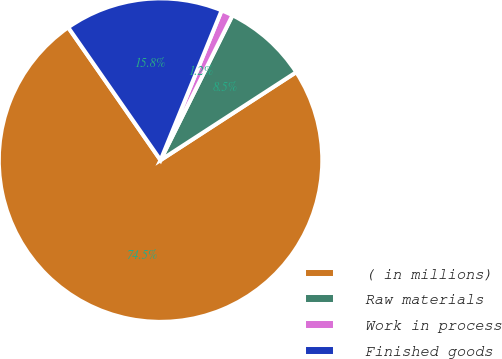Convert chart to OTSL. <chart><loc_0><loc_0><loc_500><loc_500><pie_chart><fcel>( in millions)<fcel>Raw materials<fcel>Work in process<fcel>Finished goods<nl><fcel>74.48%<fcel>8.51%<fcel>1.17%<fcel>15.84%<nl></chart> 